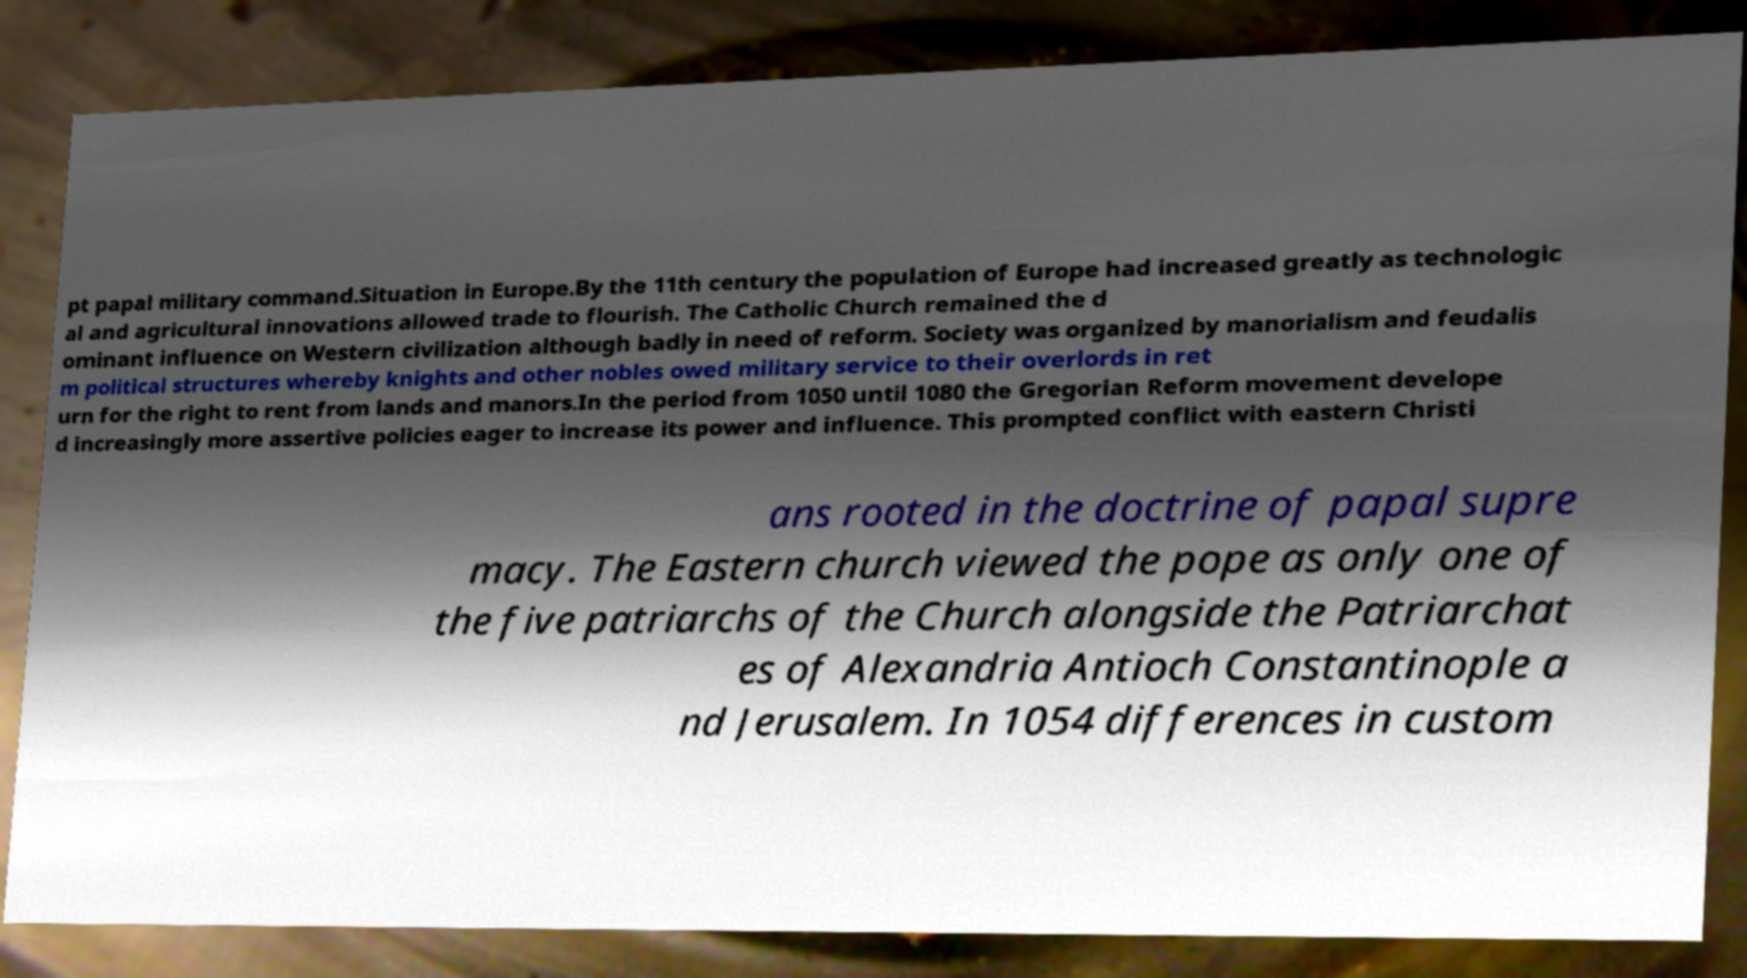For documentation purposes, I need the text within this image transcribed. Could you provide that? pt papal military command.Situation in Europe.By the 11th century the population of Europe had increased greatly as technologic al and agricultural innovations allowed trade to flourish. The Catholic Church remained the d ominant influence on Western civilization although badly in need of reform. Society was organized by manorialism and feudalis m political structures whereby knights and other nobles owed military service to their overlords in ret urn for the right to rent from lands and manors.In the period from 1050 until 1080 the Gregorian Reform movement develope d increasingly more assertive policies eager to increase its power and influence. This prompted conflict with eastern Christi ans rooted in the doctrine of papal supre macy. The Eastern church viewed the pope as only one of the five patriarchs of the Church alongside the Patriarchat es of Alexandria Antioch Constantinople a nd Jerusalem. In 1054 differences in custom 